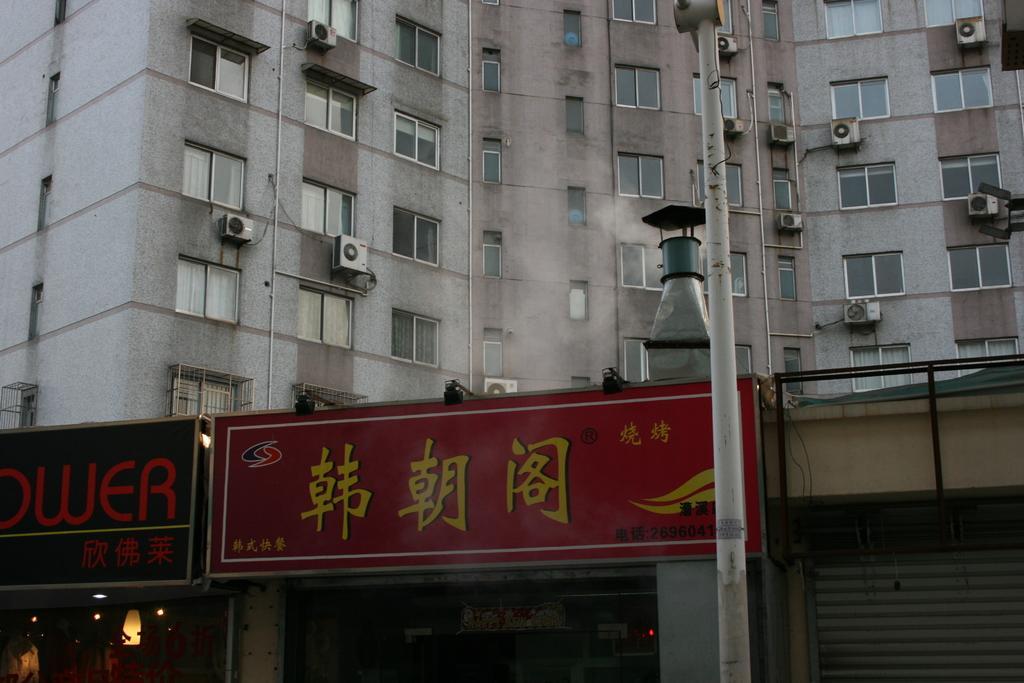Please provide a concise description of this image. In this picture I can see buildings on which I can see windows and other objects attached to the wall. In the front of the image I can see a pole and shops which has boards and shutter. 